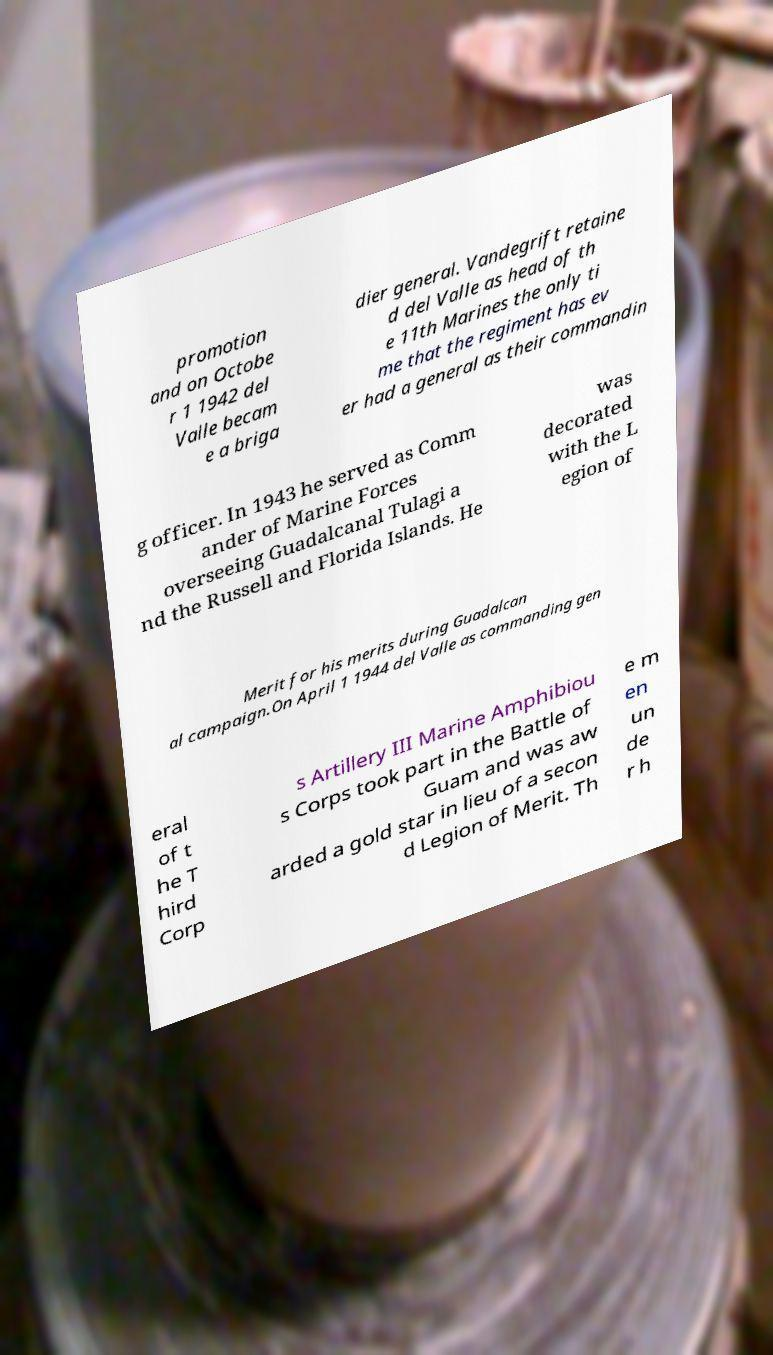Can you accurately transcribe the text from the provided image for me? promotion and on Octobe r 1 1942 del Valle becam e a briga dier general. Vandegrift retaine d del Valle as head of th e 11th Marines the only ti me that the regiment has ev er had a general as their commandin g officer. In 1943 he served as Comm ander of Marine Forces overseeing Guadalcanal Tulagi a nd the Russell and Florida Islands. He was decorated with the L egion of Merit for his merits during Guadalcan al campaign.On April 1 1944 del Valle as commanding gen eral of t he T hird Corp s Artillery III Marine Amphibiou s Corps took part in the Battle of Guam and was aw arded a gold star in lieu of a secon d Legion of Merit. Th e m en un de r h 